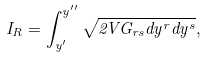<formula> <loc_0><loc_0><loc_500><loc_500>I _ { R } = \int _ { y ^ { \prime } } ^ { y ^ { \prime \prime } } \sqrt { 2 V G _ { r s } d y ^ { r } d y ^ { s } } ,</formula> 